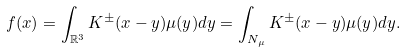Convert formula to latex. <formula><loc_0><loc_0><loc_500><loc_500>f ( x ) = \int _ { \mathbb { R } ^ { 3 } } K ^ { \pm } ( x - y ) \mu ( y ) d y = \int _ { N _ { \mu } } K ^ { \pm } ( x - y ) \mu ( y ) d y .</formula> 